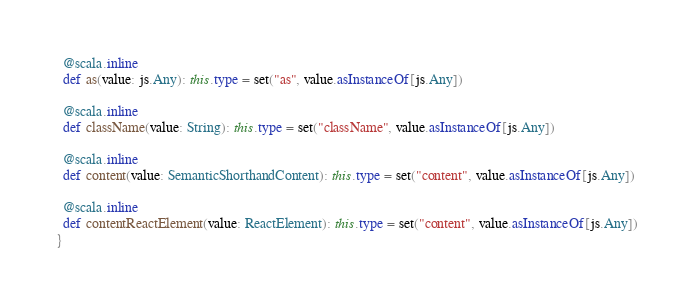Convert code to text. <code><loc_0><loc_0><loc_500><loc_500><_Scala_>  @scala.inline
  def as(value: js.Any): this.type = set("as", value.asInstanceOf[js.Any])
  
  @scala.inline
  def className(value: String): this.type = set("className", value.asInstanceOf[js.Any])
  
  @scala.inline
  def content(value: SemanticShorthandContent): this.type = set("content", value.asInstanceOf[js.Any])
  
  @scala.inline
  def contentReactElement(value: ReactElement): this.type = set("content", value.asInstanceOf[js.Any])
}
</code> 